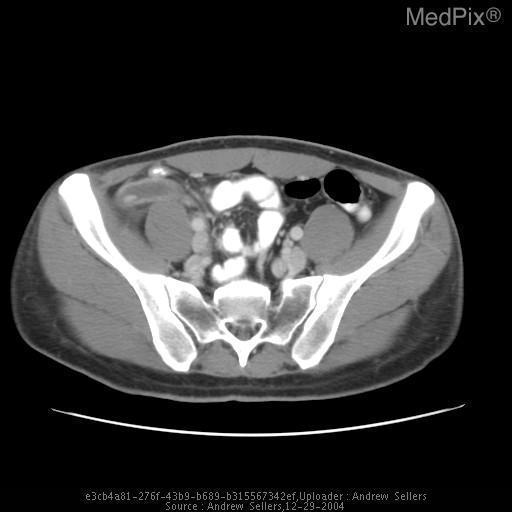Is there fat stranding around the appendix?
Short answer required. Yes. Does the appendix appear normal?
Write a very short answer. No. Was contrast used with this image?
Quick response, please. Yes. 